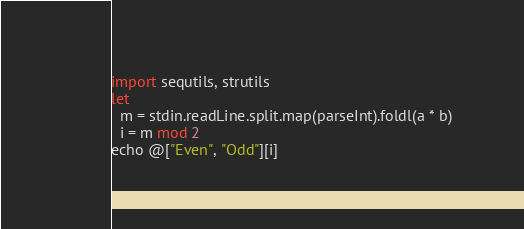<code> <loc_0><loc_0><loc_500><loc_500><_Nim_>import sequtils, strutils
let
  m = stdin.readLine.split.map(parseInt).foldl(a * b)
  i = m mod 2
echo @["Even", "Odd"][i]
</code> 